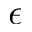<formula> <loc_0><loc_0><loc_500><loc_500>\epsilon</formula> 